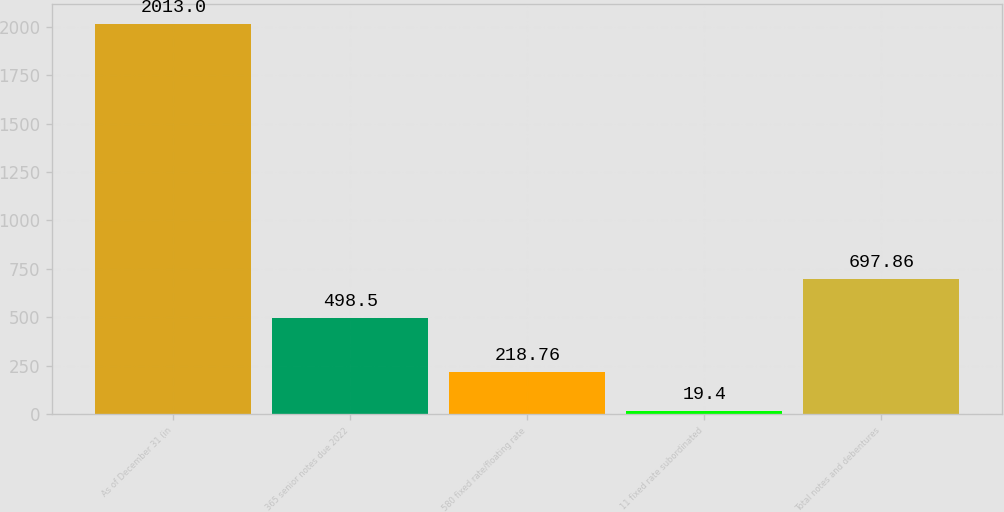Convert chart. <chart><loc_0><loc_0><loc_500><loc_500><bar_chart><fcel>As of December 31 (in<fcel>365 senior notes due 2022<fcel>580 fixed rate/floating rate<fcel>11 fixed rate subordinated<fcel>Total notes and debentures<nl><fcel>2013<fcel>498.5<fcel>218.76<fcel>19.4<fcel>697.86<nl></chart> 